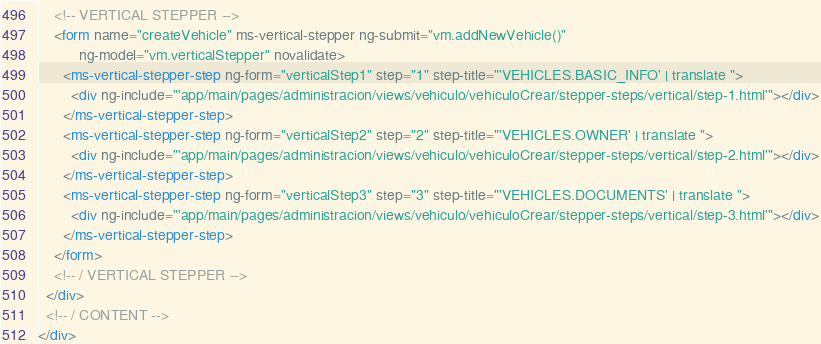Convert code to text. <code><loc_0><loc_0><loc_500><loc_500><_HTML_>    <!-- VERTICAL STEPPER -->
    <form name="createVehicle" ms-vertical-stepper ng-submit="vm.addNewVehicle()"
          ng-model="vm.verticalStepper" novalidate>
      <ms-vertical-stepper-step ng-form="verticalStep1" step="1" step-title="'VEHICLES.BASIC_INFO' | translate ">
        <div ng-include="'app/main/pages/administracion/views/vehiculo/vehiculoCrear/stepper-steps/vertical/step-1.html'"></div>
      </ms-vertical-stepper-step>
      <ms-vertical-stepper-step ng-form="verticalStep2" step="2" step-title="'VEHICLES.OWNER' | translate ">
        <div ng-include="'app/main/pages/administracion/views/vehiculo/vehiculoCrear/stepper-steps/vertical/step-2.html'"></div>
      </ms-vertical-stepper-step>
      <ms-vertical-stepper-step ng-form="verticalStep3" step="3" step-title="'VEHICLES.DOCUMENTS' | translate ">
        <div ng-include="'app/main/pages/administracion/views/vehiculo/vehiculoCrear/stepper-steps/vertical/step-3.html'"></div>
      </ms-vertical-stepper-step>
    </form>
    <!-- / VERTICAL STEPPER -->
  </div>
  <!-- / CONTENT -->
</div>
</code> 